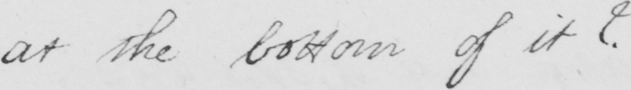Please provide the text content of this handwritten line. at the bottom of it ?   _ 